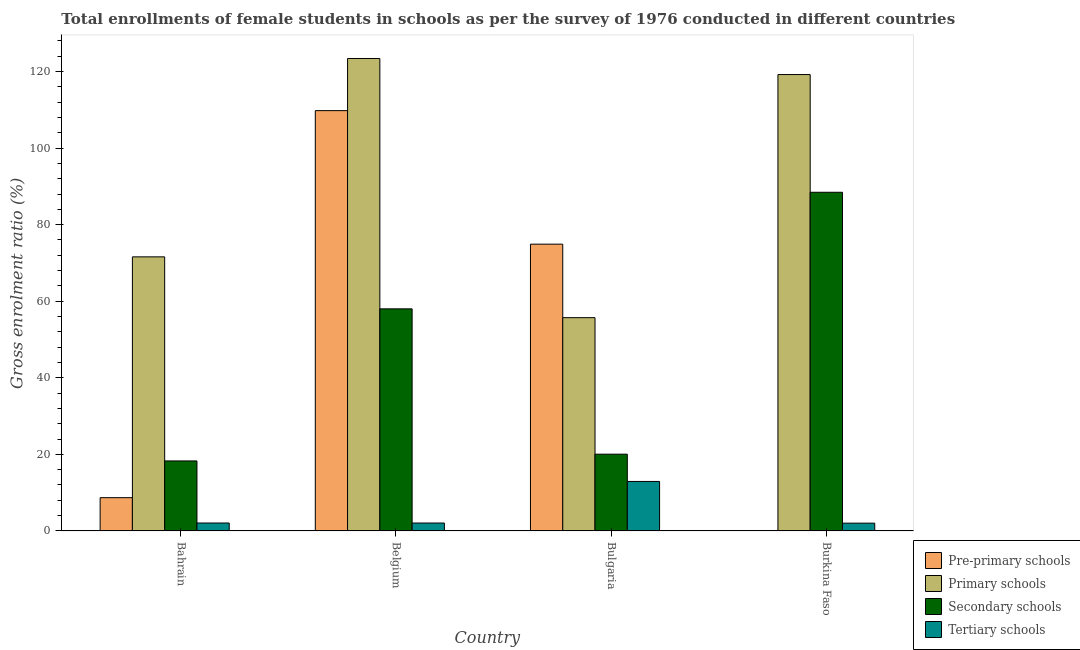How many groups of bars are there?
Your answer should be very brief. 4. Are the number of bars per tick equal to the number of legend labels?
Offer a very short reply. Yes. How many bars are there on the 4th tick from the left?
Offer a very short reply. 4. What is the label of the 4th group of bars from the left?
Your answer should be very brief. Burkina Faso. In how many cases, is the number of bars for a given country not equal to the number of legend labels?
Your response must be concise. 0. What is the gross enrolment ratio(female) in secondary schools in Burkina Faso?
Ensure brevity in your answer.  88.46. Across all countries, what is the maximum gross enrolment ratio(female) in tertiary schools?
Provide a short and direct response. 12.93. Across all countries, what is the minimum gross enrolment ratio(female) in secondary schools?
Provide a short and direct response. 18.29. In which country was the gross enrolment ratio(female) in tertiary schools maximum?
Your response must be concise. Bulgaria. In which country was the gross enrolment ratio(female) in tertiary schools minimum?
Provide a short and direct response. Burkina Faso. What is the total gross enrolment ratio(female) in pre-primary schools in the graph?
Offer a very short reply. 193.47. What is the difference between the gross enrolment ratio(female) in pre-primary schools in Bahrain and that in Burkina Faso?
Your answer should be compact. 8.6. What is the difference between the gross enrolment ratio(female) in secondary schools in Burkina Faso and the gross enrolment ratio(female) in tertiary schools in Bahrain?
Make the answer very short. 86.39. What is the average gross enrolment ratio(female) in pre-primary schools per country?
Offer a terse response. 48.37. What is the difference between the gross enrolment ratio(female) in secondary schools and gross enrolment ratio(female) in pre-primary schools in Bulgaria?
Give a very brief answer. -54.86. What is the ratio of the gross enrolment ratio(female) in pre-primary schools in Bahrain to that in Bulgaria?
Give a very brief answer. 0.12. Is the difference between the gross enrolment ratio(female) in secondary schools in Bahrain and Bulgaria greater than the difference between the gross enrolment ratio(female) in pre-primary schools in Bahrain and Bulgaria?
Offer a terse response. Yes. What is the difference between the highest and the second highest gross enrolment ratio(female) in tertiary schools?
Offer a very short reply. 10.86. What is the difference between the highest and the lowest gross enrolment ratio(female) in pre-primary schools?
Provide a short and direct response. 109.69. Is the sum of the gross enrolment ratio(female) in pre-primary schools in Belgium and Burkina Faso greater than the maximum gross enrolment ratio(female) in secondary schools across all countries?
Give a very brief answer. Yes. What does the 1st bar from the left in Burkina Faso represents?
Provide a succinct answer. Pre-primary schools. What does the 3rd bar from the right in Burkina Faso represents?
Offer a terse response. Primary schools. Is it the case that in every country, the sum of the gross enrolment ratio(female) in pre-primary schools and gross enrolment ratio(female) in primary schools is greater than the gross enrolment ratio(female) in secondary schools?
Your response must be concise. Yes. Are all the bars in the graph horizontal?
Provide a succinct answer. No. How many countries are there in the graph?
Your answer should be very brief. 4. What is the difference between two consecutive major ticks on the Y-axis?
Keep it short and to the point. 20. Are the values on the major ticks of Y-axis written in scientific E-notation?
Provide a short and direct response. No. Where does the legend appear in the graph?
Keep it short and to the point. Bottom right. How many legend labels are there?
Give a very brief answer. 4. How are the legend labels stacked?
Offer a terse response. Vertical. What is the title of the graph?
Your response must be concise. Total enrollments of female students in schools as per the survey of 1976 conducted in different countries. Does "Labor Taxes" appear as one of the legend labels in the graph?
Offer a terse response. No. What is the label or title of the X-axis?
Offer a terse response. Country. What is the label or title of the Y-axis?
Your response must be concise. Gross enrolment ratio (%). What is the Gross enrolment ratio (%) of Pre-primary schools in Bahrain?
Offer a terse response. 8.69. What is the Gross enrolment ratio (%) of Primary schools in Bahrain?
Your answer should be very brief. 71.59. What is the Gross enrolment ratio (%) in Secondary schools in Bahrain?
Provide a short and direct response. 18.29. What is the Gross enrolment ratio (%) in Tertiary schools in Bahrain?
Your answer should be very brief. 2.07. What is the Gross enrolment ratio (%) in Pre-primary schools in Belgium?
Give a very brief answer. 109.78. What is the Gross enrolment ratio (%) of Primary schools in Belgium?
Your response must be concise. 123.4. What is the Gross enrolment ratio (%) in Secondary schools in Belgium?
Ensure brevity in your answer.  58.01. What is the Gross enrolment ratio (%) of Tertiary schools in Belgium?
Your answer should be compact. 2.07. What is the Gross enrolment ratio (%) in Pre-primary schools in Bulgaria?
Give a very brief answer. 74.91. What is the Gross enrolment ratio (%) of Primary schools in Bulgaria?
Make the answer very short. 55.71. What is the Gross enrolment ratio (%) in Secondary schools in Bulgaria?
Offer a very short reply. 20.05. What is the Gross enrolment ratio (%) of Tertiary schools in Bulgaria?
Your answer should be compact. 12.93. What is the Gross enrolment ratio (%) of Pre-primary schools in Burkina Faso?
Your response must be concise. 0.09. What is the Gross enrolment ratio (%) in Primary schools in Burkina Faso?
Your answer should be compact. 119.21. What is the Gross enrolment ratio (%) of Secondary schools in Burkina Faso?
Provide a succinct answer. 88.46. What is the Gross enrolment ratio (%) of Tertiary schools in Burkina Faso?
Your answer should be compact. 2.03. Across all countries, what is the maximum Gross enrolment ratio (%) in Pre-primary schools?
Your answer should be very brief. 109.78. Across all countries, what is the maximum Gross enrolment ratio (%) of Primary schools?
Give a very brief answer. 123.4. Across all countries, what is the maximum Gross enrolment ratio (%) of Secondary schools?
Offer a very short reply. 88.46. Across all countries, what is the maximum Gross enrolment ratio (%) of Tertiary schools?
Provide a short and direct response. 12.93. Across all countries, what is the minimum Gross enrolment ratio (%) in Pre-primary schools?
Your answer should be very brief. 0.09. Across all countries, what is the minimum Gross enrolment ratio (%) of Primary schools?
Keep it short and to the point. 55.71. Across all countries, what is the minimum Gross enrolment ratio (%) in Secondary schools?
Provide a succinct answer. 18.29. Across all countries, what is the minimum Gross enrolment ratio (%) in Tertiary schools?
Give a very brief answer. 2.03. What is the total Gross enrolment ratio (%) of Pre-primary schools in the graph?
Your answer should be compact. 193.47. What is the total Gross enrolment ratio (%) of Primary schools in the graph?
Provide a short and direct response. 369.91. What is the total Gross enrolment ratio (%) in Secondary schools in the graph?
Keep it short and to the point. 184.8. What is the total Gross enrolment ratio (%) in Tertiary schools in the graph?
Offer a terse response. 19.1. What is the difference between the Gross enrolment ratio (%) in Pre-primary schools in Bahrain and that in Belgium?
Provide a short and direct response. -101.09. What is the difference between the Gross enrolment ratio (%) in Primary schools in Bahrain and that in Belgium?
Make the answer very short. -51.81. What is the difference between the Gross enrolment ratio (%) of Secondary schools in Bahrain and that in Belgium?
Provide a short and direct response. -39.72. What is the difference between the Gross enrolment ratio (%) in Tertiary schools in Bahrain and that in Belgium?
Your response must be concise. 0. What is the difference between the Gross enrolment ratio (%) of Pre-primary schools in Bahrain and that in Bulgaria?
Your answer should be very brief. -66.22. What is the difference between the Gross enrolment ratio (%) in Primary schools in Bahrain and that in Bulgaria?
Offer a terse response. 15.88. What is the difference between the Gross enrolment ratio (%) of Secondary schools in Bahrain and that in Bulgaria?
Offer a terse response. -1.76. What is the difference between the Gross enrolment ratio (%) in Tertiary schools in Bahrain and that in Bulgaria?
Your answer should be compact. -10.86. What is the difference between the Gross enrolment ratio (%) in Pre-primary schools in Bahrain and that in Burkina Faso?
Ensure brevity in your answer.  8.6. What is the difference between the Gross enrolment ratio (%) of Primary schools in Bahrain and that in Burkina Faso?
Ensure brevity in your answer.  -47.62. What is the difference between the Gross enrolment ratio (%) in Secondary schools in Bahrain and that in Burkina Faso?
Offer a terse response. -70.17. What is the difference between the Gross enrolment ratio (%) in Tertiary schools in Bahrain and that in Burkina Faso?
Make the answer very short. 0.04. What is the difference between the Gross enrolment ratio (%) of Pre-primary schools in Belgium and that in Bulgaria?
Offer a terse response. 34.88. What is the difference between the Gross enrolment ratio (%) in Primary schools in Belgium and that in Bulgaria?
Your response must be concise. 67.69. What is the difference between the Gross enrolment ratio (%) in Secondary schools in Belgium and that in Bulgaria?
Your answer should be compact. 37.96. What is the difference between the Gross enrolment ratio (%) of Tertiary schools in Belgium and that in Bulgaria?
Offer a terse response. -10.86. What is the difference between the Gross enrolment ratio (%) of Pre-primary schools in Belgium and that in Burkina Faso?
Ensure brevity in your answer.  109.69. What is the difference between the Gross enrolment ratio (%) of Primary schools in Belgium and that in Burkina Faso?
Offer a terse response. 4.2. What is the difference between the Gross enrolment ratio (%) in Secondary schools in Belgium and that in Burkina Faso?
Your answer should be very brief. -30.45. What is the difference between the Gross enrolment ratio (%) of Tertiary schools in Belgium and that in Burkina Faso?
Provide a short and direct response. 0.03. What is the difference between the Gross enrolment ratio (%) of Pre-primary schools in Bulgaria and that in Burkina Faso?
Ensure brevity in your answer.  74.82. What is the difference between the Gross enrolment ratio (%) in Primary schools in Bulgaria and that in Burkina Faso?
Your answer should be very brief. -63.5. What is the difference between the Gross enrolment ratio (%) in Secondary schools in Bulgaria and that in Burkina Faso?
Provide a short and direct response. -68.41. What is the difference between the Gross enrolment ratio (%) of Tertiary schools in Bulgaria and that in Burkina Faso?
Offer a very short reply. 10.89. What is the difference between the Gross enrolment ratio (%) of Pre-primary schools in Bahrain and the Gross enrolment ratio (%) of Primary schools in Belgium?
Offer a terse response. -114.71. What is the difference between the Gross enrolment ratio (%) of Pre-primary schools in Bahrain and the Gross enrolment ratio (%) of Secondary schools in Belgium?
Ensure brevity in your answer.  -49.32. What is the difference between the Gross enrolment ratio (%) in Pre-primary schools in Bahrain and the Gross enrolment ratio (%) in Tertiary schools in Belgium?
Ensure brevity in your answer.  6.62. What is the difference between the Gross enrolment ratio (%) in Primary schools in Bahrain and the Gross enrolment ratio (%) in Secondary schools in Belgium?
Offer a terse response. 13.58. What is the difference between the Gross enrolment ratio (%) of Primary schools in Bahrain and the Gross enrolment ratio (%) of Tertiary schools in Belgium?
Offer a very short reply. 69.52. What is the difference between the Gross enrolment ratio (%) in Secondary schools in Bahrain and the Gross enrolment ratio (%) in Tertiary schools in Belgium?
Your answer should be very brief. 16.22. What is the difference between the Gross enrolment ratio (%) of Pre-primary schools in Bahrain and the Gross enrolment ratio (%) of Primary schools in Bulgaria?
Provide a short and direct response. -47.02. What is the difference between the Gross enrolment ratio (%) of Pre-primary schools in Bahrain and the Gross enrolment ratio (%) of Secondary schools in Bulgaria?
Ensure brevity in your answer.  -11.36. What is the difference between the Gross enrolment ratio (%) of Pre-primary schools in Bahrain and the Gross enrolment ratio (%) of Tertiary schools in Bulgaria?
Offer a very short reply. -4.24. What is the difference between the Gross enrolment ratio (%) of Primary schools in Bahrain and the Gross enrolment ratio (%) of Secondary schools in Bulgaria?
Offer a very short reply. 51.54. What is the difference between the Gross enrolment ratio (%) in Primary schools in Bahrain and the Gross enrolment ratio (%) in Tertiary schools in Bulgaria?
Give a very brief answer. 58.66. What is the difference between the Gross enrolment ratio (%) of Secondary schools in Bahrain and the Gross enrolment ratio (%) of Tertiary schools in Bulgaria?
Make the answer very short. 5.36. What is the difference between the Gross enrolment ratio (%) in Pre-primary schools in Bahrain and the Gross enrolment ratio (%) in Primary schools in Burkina Faso?
Ensure brevity in your answer.  -110.52. What is the difference between the Gross enrolment ratio (%) of Pre-primary schools in Bahrain and the Gross enrolment ratio (%) of Secondary schools in Burkina Faso?
Your answer should be compact. -79.77. What is the difference between the Gross enrolment ratio (%) of Pre-primary schools in Bahrain and the Gross enrolment ratio (%) of Tertiary schools in Burkina Faso?
Give a very brief answer. 6.66. What is the difference between the Gross enrolment ratio (%) in Primary schools in Bahrain and the Gross enrolment ratio (%) in Secondary schools in Burkina Faso?
Your answer should be very brief. -16.87. What is the difference between the Gross enrolment ratio (%) in Primary schools in Bahrain and the Gross enrolment ratio (%) in Tertiary schools in Burkina Faso?
Your answer should be very brief. 69.56. What is the difference between the Gross enrolment ratio (%) in Secondary schools in Bahrain and the Gross enrolment ratio (%) in Tertiary schools in Burkina Faso?
Give a very brief answer. 16.25. What is the difference between the Gross enrolment ratio (%) of Pre-primary schools in Belgium and the Gross enrolment ratio (%) of Primary schools in Bulgaria?
Keep it short and to the point. 54.07. What is the difference between the Gross enrolment ratio (%) in Pre-primary schools in Belgium and the Gross enrolment ratio (%) in Secondary schools in Bulgaria?
Your answer should be compact. 89.74. What is the difference between the Gross enrolment ratio (%) of Pre-primary schools in Belgium and the Gross enrolment ratio (%) of Tertiary schools in Bulgaria?
Your answer should be compact. 96.86. What is the difference between the Gross enrolment ratio (%) in Primary schools in Belgium and the Gross enrolment ratio (%) in Secondary schools in Bulgaria?
Offer a terse response. 103.36. What is the difference between the Gross enrolment ratio (%) of Primary schools in Belgium and the Gross enrolment ratio (%) of Tertiary schools in Bulgaria?
Provide a succinct answer. 110.48. What is the difference between the Gross enrolment ratio (%) of Secondary schools in Belgium and the Gross enrolment ratio (%) of Tertiary schools in Bulgaria?
Make the answer very short. 45.08. What is the difference between the Gross enrolment ratio (%) of Pre-primary schools in Belgium and the Gross enrolment ratio (%) of Primary schools in Burkina Faso?
Make the answer very short. -9.42. What is the difference between the Gross enrolment ratio (%) in Pre-primary schools in Belgium and the Gross enrolment ratio (%) in Secondary schools in Burkina Faso?
Provide a short and direct response. 21.33. What is the difference between the Gross enrolment ratio (%) in Pre-primary schools in Belgium and the Gross enrolment ratio (%) in Tertiary schools in Burkina Faso?
Keep it short and to the point. 107.75. What is the difference between the Gross enrolment ratio (%) of Primary schools in Belgium and the Gross enrolment ratio (%) of Secondary schools in Burkina Faso?
Provide a succinct answer. 34.94. What is the difference between the Gross enrolment ratio (%) of Primary schools in Belgium and the Gross enrolment ratio (%) of Tertiary schools in Burkina Faso?
Offer a very short reply. 121.37. What is the difference between the Gross enrolment ratio (%) of Secondary schools in Belgium and the Gross enrolment ratio (%) of Tertiary schools in Burkina Faso?
Make the answer very short. 55.98. What is the difference between the Gross enrolment ratio (%) of Pre-primary schools in Bulgaria and the Gross enrolment ratio (%) of Primary schools in Burkina Faso?
Your response must be concise. -44.3. What is the difference between the Gross enrolment ratio (%) in Pre-primary schools in Bulgaria and the Gross enrolment ratio (%) in Secondary schools in Burkina Faso?
Give a very brief answer. -13.55. What is the difference between the Gross enrolment ratio (%) in Pre-primary schools in Bulgaria and the Gross enrolment ratio (%) in Tertiary schools in Burkina Faso?
Ensure brevity in your answer.  72.87. What is the difference between the Gross enrolment ratio (%) of Primary schools in Bulgaria and the Gross enrolment ratio (%) of Secondary schools in Burkina Faso?
Offer a very short reply. -32.75. What is the difference between the Gross enrolment ratio (%) in Primary schools in Bulgaria and the Gross enrolment ratio (%) in Tertiary schools in Burkina Faso?
Ensure brevity in your answer.  53.68. What is the difference between the Gross enrolment ratio (%) of Secondary schools in Bulgaria and the Gross enrolment ratio (%) of Tertiary schools in Burkina Faso?
Your response must be concise. 18.01. What is the average Gross enrolment ratio (%) of Pre-primary schools per country?
Your answer should be compact. 48.37. What is the average Gross enrolment ratio (%) in Primary schools per country?
Provide a succinct answer. 92.48. What is the average Gross enrolment ratio (%) of Secondary schools per country?
Your response must be concise. 46.2. What is the average Gross enrolment ratio (%) of Tertiary schools per country?
Your response must be concise. 4.78. What is the difference between the Gross enrolment ratio (%) in Pre-primary schools and Gross enrolment ratio (%) in Primary schools in Bahrain?
Ensure brevity in your answer.  -62.9. What is the difference between the Gross enrolment ratio (%) in Pre-primary schools and Gross enrolment ratio (%) in Secondary schools in Bahrain?
Provide a short and direct response. -9.6. What is the difference between the Gross enrolment ratio (%) of Pre-primary schools and Gross enrolment ratio (%) of Tertiary schools in Bahrain?
Your answer should be compact. 6.62. What is the difference between the Gross enrolment ratio (%) in Primary schools and Gross enrolment ratio (%) in Secondary schools in Bahrain?
Your answer should be compact. 53.31. What is the difference between the Gross enrolment ratio (%) in Primary schools and Gross enrolment ratio (%) in Tertiary schools in Bahrain?
Your response must be concise. 69.52. What is the difference between the Gross enrolment ratio (%) of Secondary schools and Gross enrolment ratio (%) of Tertiary schools in Bahrain?
Your response must be concise. 16.22. What is the difference between the Gross enrolment ratio (%) in Pre-primary schools and Gross enrolment ratio (%) in Primary schools in Belgium?
Your answer should be very brief. -13.62. What is the difference between the Gross enrolment ratio (%) of Pre-primary schools and Gross enrolment ratio (%) of Secondary schools in Belgium?
Your answer should be compact. 51.77. What is the difference between the Gross enrolment ratio (%) in Pre-primary schools and Gross enrolment ratio (%) in Tertiary schools in Belgium?
Provide a succinct answer. 107.72. What is the difference between the Gross enrolment ratio (%) in Primary schools and Gross enrolment ratio (%) in Secondary schools in Belgium?
Keep it short and to the point. 65.39. What is the difference between the Gross enrolment ratio (%) of Primary schools and Gross enrolment ratio (%) of Tertiary schools in Belgium?
Offer a terse response. 121.34. What is the difference between the Gross enrolment ratio (%) in Secondary schools and Gross enrolment ratio (%) in Tertiary schools in Belgium?
Offer a very short reply. 55.94. What is the difference between the Gross enrolment ratio (%) in Pre-primary schools and Gross enrolment ratio (%) in Primary schools in Bulgaria?
Your answer should be very brief. 19.2. What is the difference between the Gross enrolment ratio (%) in Pre-primary schools and Gross enrolment ratio (%) in Secondary schools in Bulgaria?
Make the answer very short. 54.86. What is the difference between the Gross enrolment ratio (%) in Pre-primary schools and Gross enrolment ratio (%) in Tertiary schools in Bulgaria?
Your answer should be compact. 61.98. What is the difference between the Gross enrolment ratio (%) in Primary schools and Gross enrolment ratio (%) in Secondary schools in Bulgaria?
Ensure brevity in your answer.  35.66. What is the difference between the Gross enrolment ratio (%) of Primary schools and Gross enrolment ratio (%) of Tertiary schools in Bulgaria?
Provide a short and direct response. 42.78. What is the difference between the Gross enrolment ratio (%) of Secondary schools and Gross enrolment ratio (%) of Tertiary schools in Bulgaria?
Offer a very short reply. 7.12. What is the difference between the Gross enrolment ratio (%) of Pre-primary schools and Gross enrolment ratio (%) of Primary schools in Burkina Faso?
Offer a very short reply. -119.12. What is the difference between the Gross enrolment ratio (%) of Pre-primary schools and Gross enrolment ratio (%) of Secondary schools in Burkina Faso?
Offer a very short reply. -88.37. What is the difference between the Gross enrolment ratio (%) of Pre-primary schools and Gross enrolment ratio (%) of Tertiary schools in Burkina Faso?
Give a very brief answer. -1.94. What is the difference between the Gross enrolment ratio (%) in Primary schools and Gross enrolment ratio (%) in Secondary schools in Burkina Faso?
Make the answer very short. 30.75. What is the difference between the Gross enrolment ratio (%) in Primary schools and Gross enrolment ratio (%) in Tertiary schools in Burkina Faso?
Your answer should be very brief. 117.17. What is the difference between the Gross enrolment ratio (%) in Secondary schools and Gross enrolment ratio (%) in Tertiary schools in Burkina Faso?
Keep it short and to the point. 86.42. What is the ratio of the Gross enrolment ratio (%) in Pre-primary schools in Bahrain to that in Belgium?
Give a very brief answer. 0.08. What is the ratio of the Gross enrolment ratio (%) of Primary schools in Bahrain to that in Belgium?
Provide a succinct answer. 0.58. What is the ratio of the Gross enrolment ratio (%) of Secondary schools in Bahrain to that in Belgium?
Your answer should be very brief. 0.32. What is the ratio of the Gross enrolment ratio (%) in Tertiary schools in Bahrain to that in Belgium?
Provide a succinct answer. 1. What is the ratio of the Gross enrolment ratio (%) in Pre-primary schools in Bahrain to that in Bulgaria?
Your answer should be very brief. 0.12. What is the ratio of the Gross enrolment ratio (%) of Primary schools in Bahrain to that in Bulgaria?
Give a very brief answer. 1.29. What is the ratio of the Gross enrolment ratio (%) of Secondary schools in Bahrain to that in Bulgaria?
Your answer should be very brief. 0.91. What is the ratio of the Gross enrolment ratio (%) in Tertiary schools in Bahrain to that in Bulgaria?
Ensure brevity in your answer.  0.16. What is the ratio of the Gross enrolment ratio (%) of Pre-primary schools in Bahrain to that in Burkina Faso?
Your answer should be very brief. 96.86. What is the ratio of the Gross enrolment ratio (%) of Primary schools in Bahrain to that in Burkina Faso?
Provide a short and direct response. 0.6. What is the ratio of the Gross enrolment ratio (%) in Secondary schools in Bahrain to that in Burkina Faso?
Make the answer very short. 0.21. What is the ratio of the Gross enrolment ratio (%) in Tertiary schools in Bahrain to that in Burkina Faso?
Give a very brief answer. 1.02. What is the ratio of the Gross enrolment ratio (%) in Pre-primary schools in Belgium to that in Bulgaria?
Offer a very short reply. 1.47. What is the ratio of the Gross enrolment ratio (%) in Primary schools in Belgium to that in Bulgaria?
Provide a succinct answer. 2.22. What is the ratio of the Gross enrolment ratio (%) of Secondary schools in Belgium to that in Bulgaria?
Ensure brevity in your answer.  2.89. What is the ratio of the Gross enrolment ratio (%) in Tertiary schools in Belgium to that in Bulgaria?
Offer a very short reply. 0.16. What is the ratio of the Gross enrolment ratio (%) of Pre-primary schools in Belgium to that in Burkina Faso?
Provide a short and direct response. 1223.63. What is the ratio of the Gross enrolment ratio (%) of Primary schools in Belgium to that in Burkina Faso?
Your answer should be compact. 1.04. What is the ratio of the Gross enrolment ratio (%) of Secondary schools in Belgium to that in Burkina Faso?
Your response must be concise. 0.66. What is the ratio of the Gross enrolment ratio (%) in Tertiary schools in Belgium to that in Burkina Faso?
Give a very brief answer. 1.02. What is the ratio of the Gross enrolment ratio (%) in Pre-primary schools in Bulgaria to that in Burkina Faso?
Offer a terse response. 834.88. What is the ratio of the Gross enrolment ratio (%) of Primary schools in Bulgaria to that in Burkina Faso?
Offer a very short reply. 0.47. What is the ratio of the Gross enrolment ratio (%) in Secondary schools in Bulgaria to that in Burkina Faso?
Provide a short and direct response. 0.23. What is the ratio of the Gross enrolment ratio (%) in Tertiary schools in Bulgaria to that in Burkina Faso?
Give a very brief answer. 6.35. What is the difference between the highest and the second highest Gross enrolment ratio (%) in Pre-primary schools?
Ensure brevity in your answer.  34.88. What is the difference between the highest and the second highest Gross enrolment ratio (%) of Primary schools?
Your answer should be very brief. 4.2. What is the difference between the highest and the second highest Gross enrolment ratio (%) of Secondary schools?
Give a very brief answer. 30.45. What is the difference between the highest and the second highest Gross enrolment ratio (%) of Tertiary schools?
Your response must be concise. 10.86. What is the difference between the highest and the lowest Gross enrolment ratio (%) in Pre-primary schools?
Ensure brevity in your answer.  109.69. What is the difference between the highest and the lowest Gross enrolment ratio (%) in Primary schools?
Give a very brief answer. 67.69. What is the difference between the highest and the lowest Gross enrolment ratio (%) of Secondary schools?
Offer a very short reply. 70.17. What is the difference between the highest and the lowest Gross enrolment ratio (%) in Tertiary schools?
Your response must be concise. 10.89. 